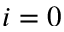Convert formula to latex. <formula><loc_0><loc_0><loc_500><loc_500>i = 0</formula> 